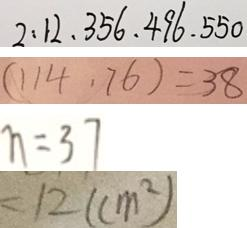Convert formula to latex. <formula><loc_0><loc_0><loc_500><loc_500>2 : 1 2 , 3 5 6 , 4 9 6 , 5 5 0 
 ( 1 1 4 . 7 6 ) = 3 8 
 n = 3 7 
 = 1 2 ( c m ^ { 2 } )</formula> 